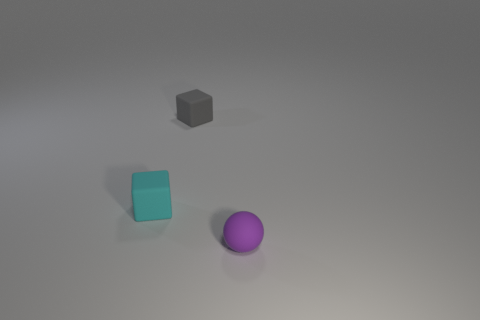How many objects are there in total? There are three objects in total: one cyan cube, one gray block, and one purple sphere. 